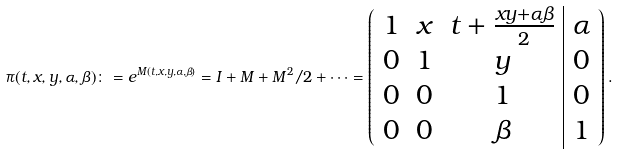Convert formula to latex. <formula><loc_0><loc_0><loc_500><loc_500>\pi ( t , x , y , \alpha , \beta ) \colon = e ^ { M ( t , x , y , \alpha , \beta ) } = I + M + M ^ { 2 } / 2 + \cdots = \left ( \begin{array} { c c c | c } 1 & x & t + \frac { x y + \alpha \beta } { 2 } & \alpha \\ 0 & 1 & y & 0 \\ 0 & 0 & 1 & 0 \\ 0 & 0 & \beta & 1 \end{array} \right ) .</formula> 